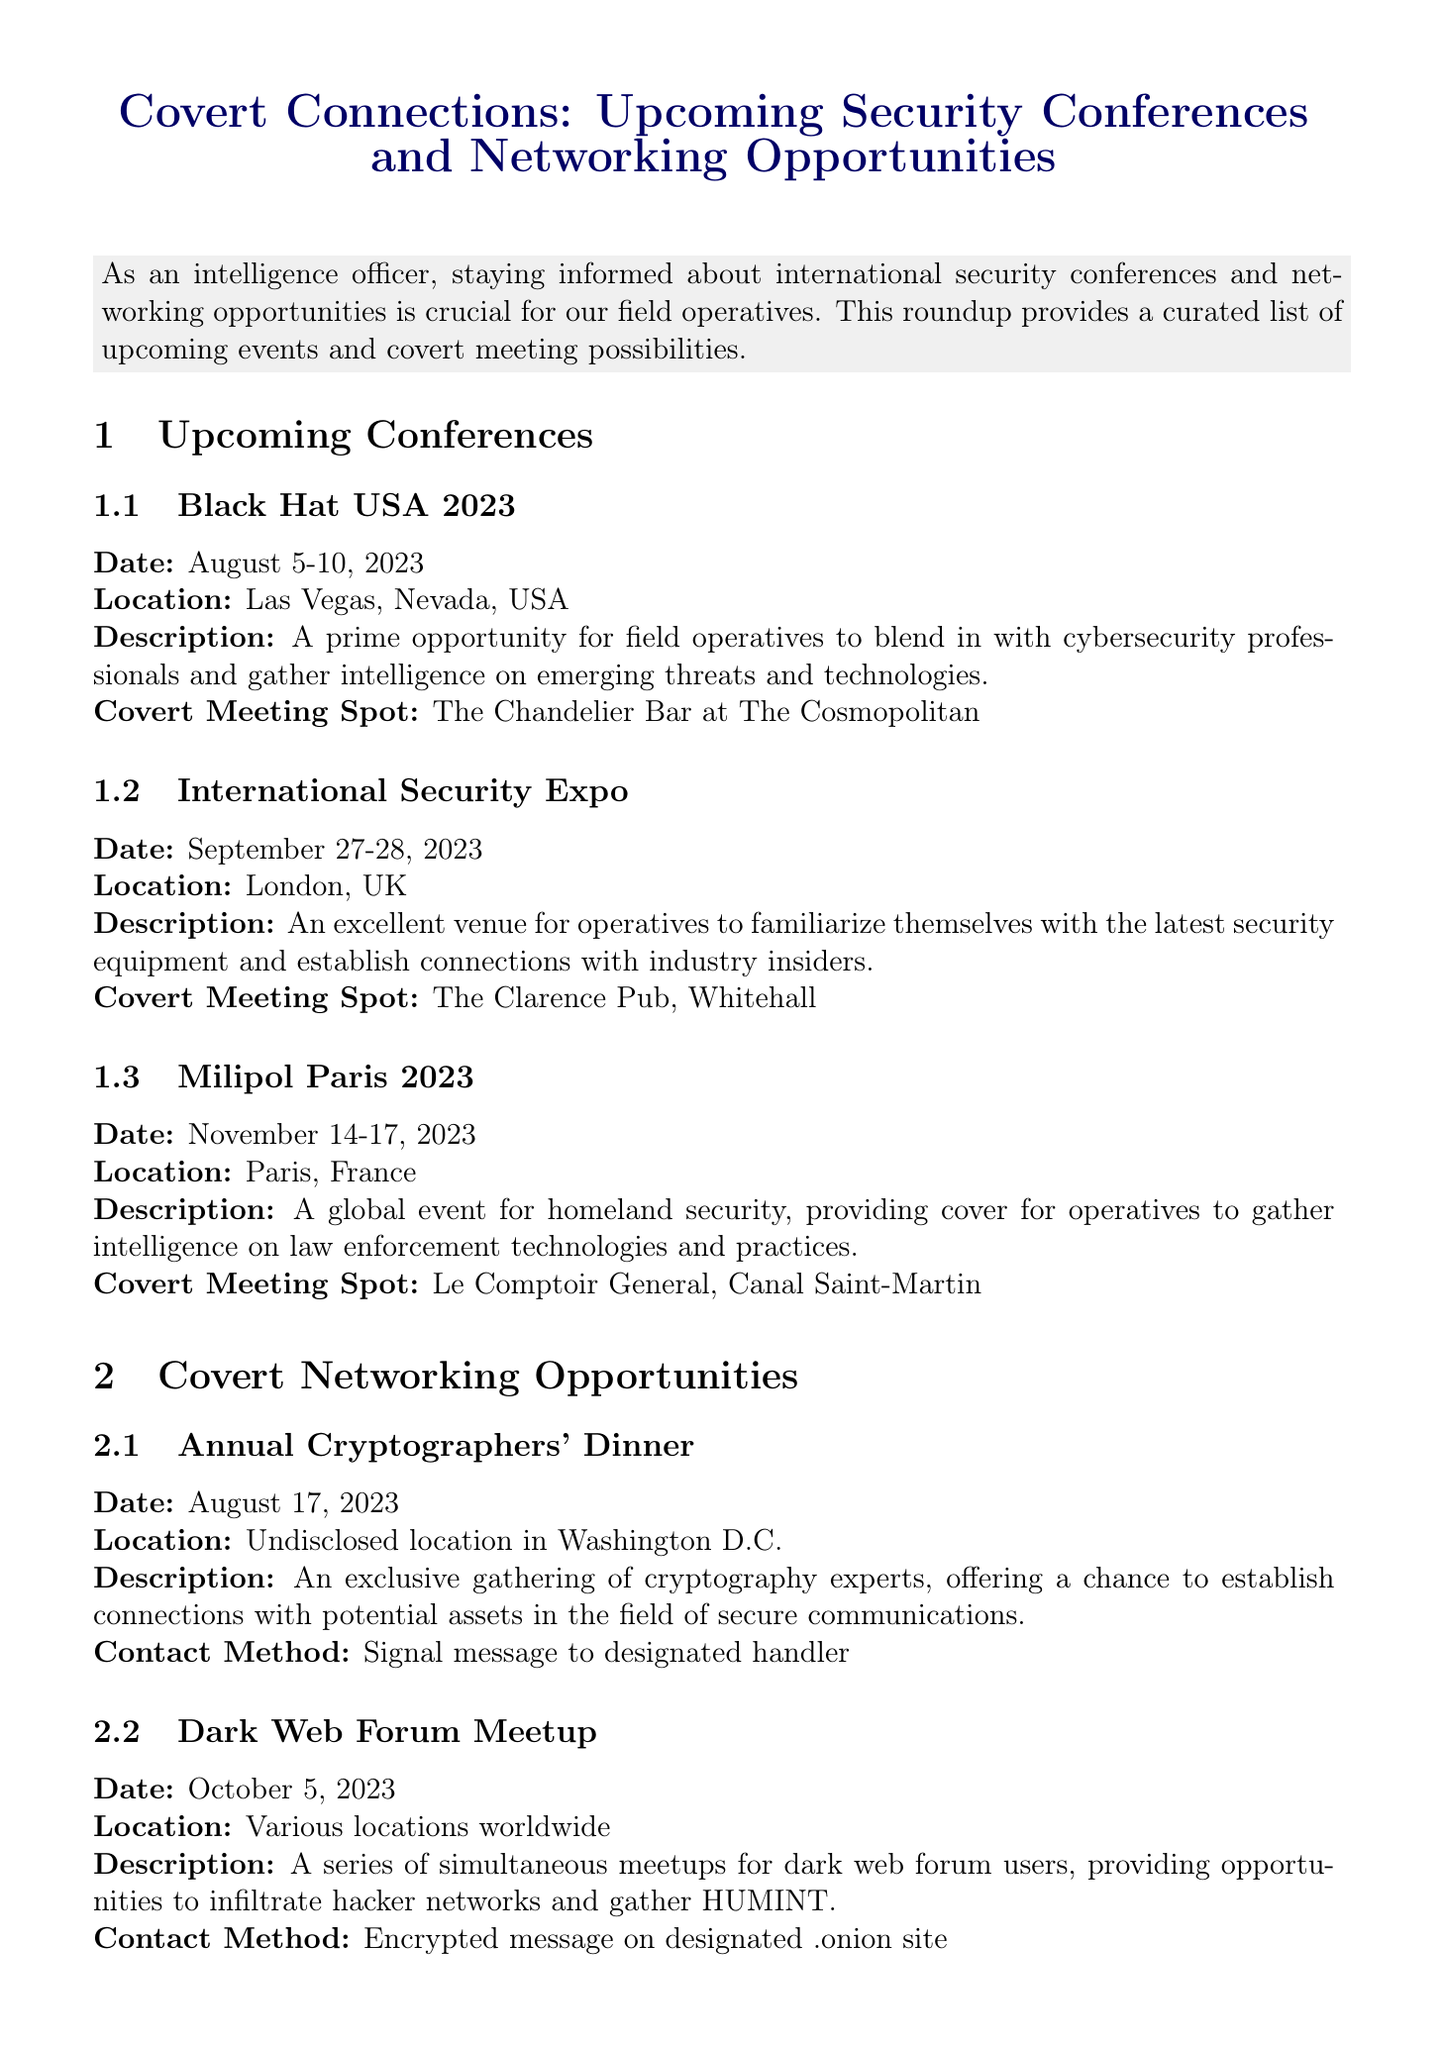What is the date of the Black Hat USA 2023 conference? The date of the conference is specifically mentioned in the document under Upcoming Conferences.
Answer: August 5-10, 2023 Where is the International Security Expo taking place? The location is explicitly stated in the Upcoming Conferences section of the document.
Answer: London, UK What is the covert meeting spot for Milipol Paris 2023? The document provides this information under the description of the Milipol Paris 2023 event.
Answer: Le Comptoir General, Canal Saint-Martin What is the date of the Annual Cryptographers' Dinner? This date is provided in the Covert Networking Opportunities section.
Answer: August 17, 2023 How is the contact made for the Dark Web Forum Meetup? The document mentions the method of contact under the description for the Dark Web Forum Meetup.
Answer: Encrypted message on designated .onion site What is the status of the Enhanced Steganography Toolkit? This information is found under the Secure Communication Updates section, detailing the status of the technology.
Answer: Ready for deployment Which event allows operatives to participate online for open-source intelligence? The document describes the Global OSINT Challenge as an online event.
Answer: Global OSINT Challenge When is the limited rollout for Quantum Key Distribution expected? This specific detail is mentioned in the availability section of the Quantum Key Distribution technology.
Answer: Q4 2023 What type of device is in development that utilizes multi-factor biometric authentication? The document directly states the type of device under Secure Communication Updates.
Answer: Biometric Encryption Devices 